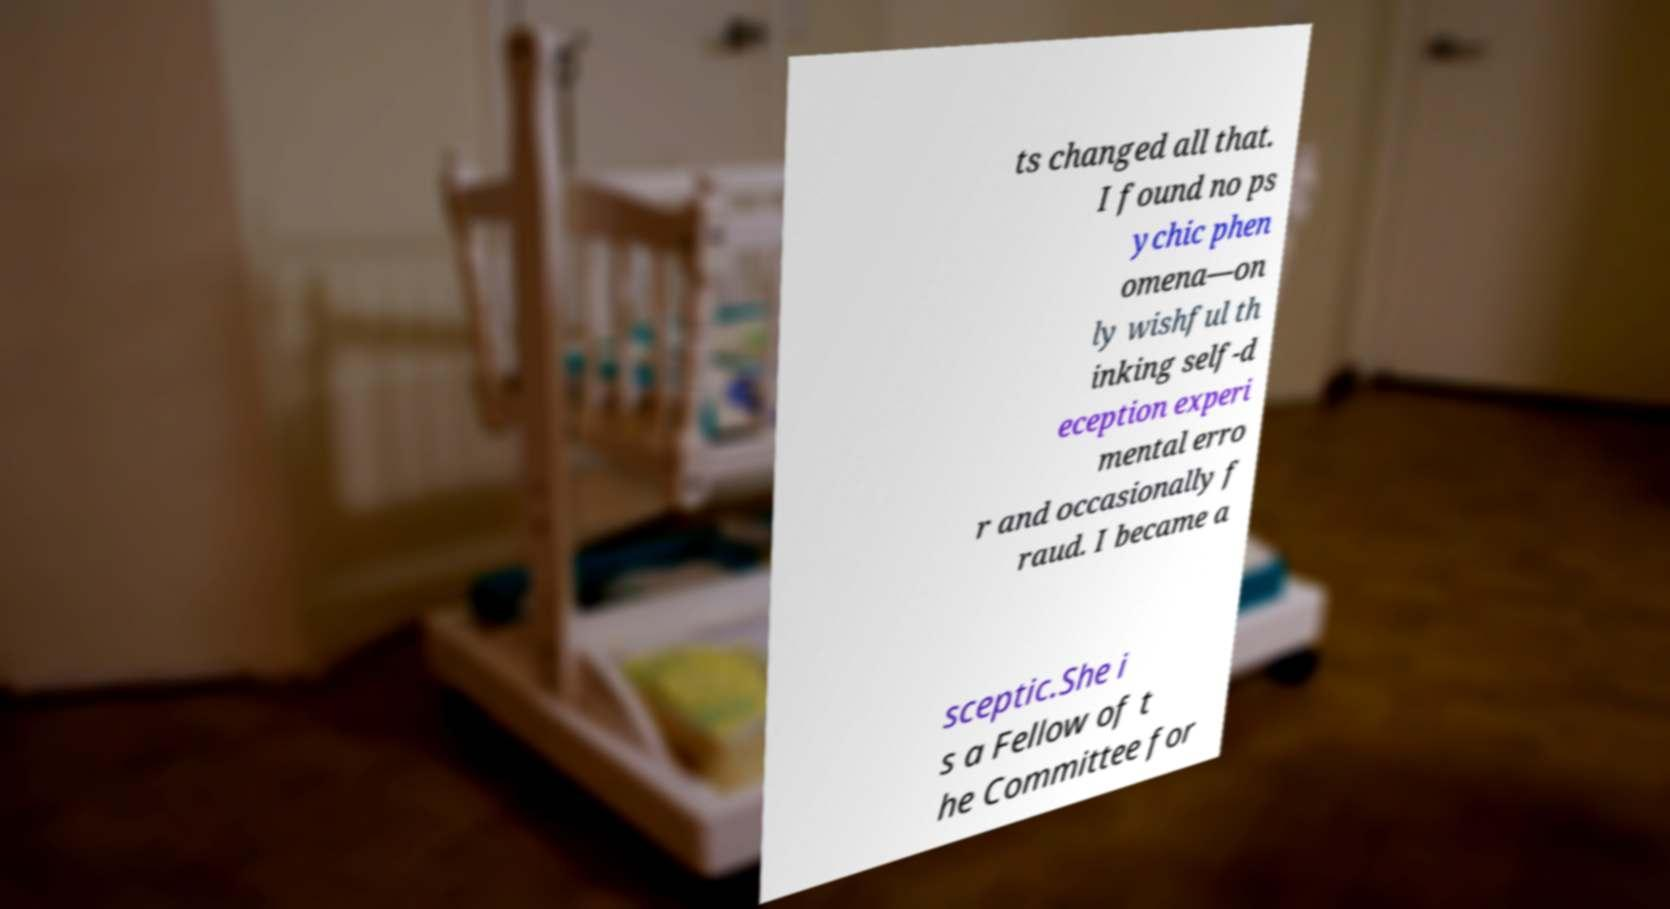For documentation purposes, I need the text within this image transcribed. Could you provide that? ts changed all that. I found no ps ychic phen omena—on ly wishful th inking self-d eception experi mental erro r and occasionally f raud. I became a sceptic.She i s a Fellow of t he Committee for 